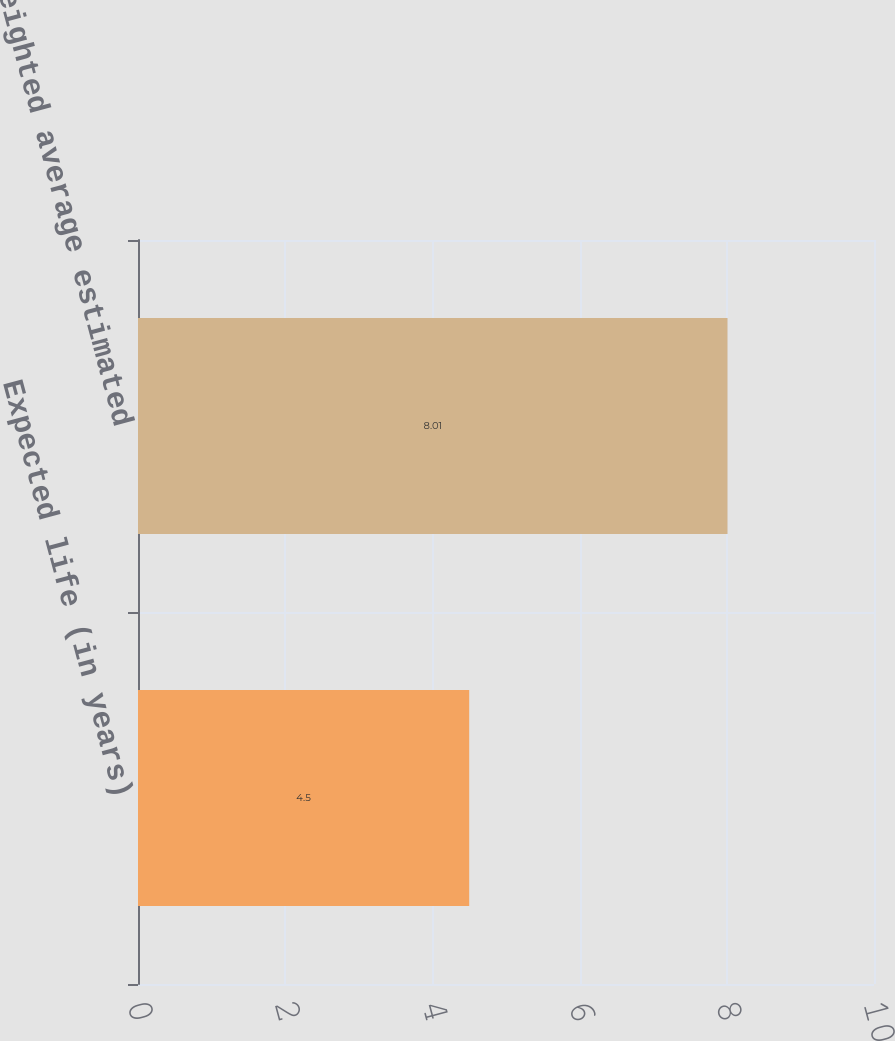Convert chart. <chart><loc_0><loc_0><loc_500><loc_500><bar_chart><fcel>Expected life (in years)<fcel>Weighted average estimated<nl><fcel>4.5<fcel>8.01<nl></chart> 